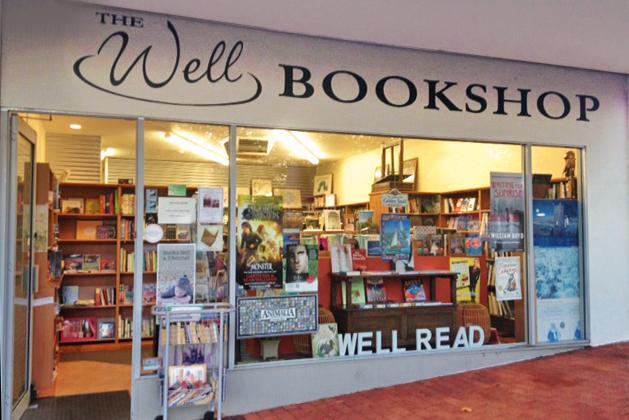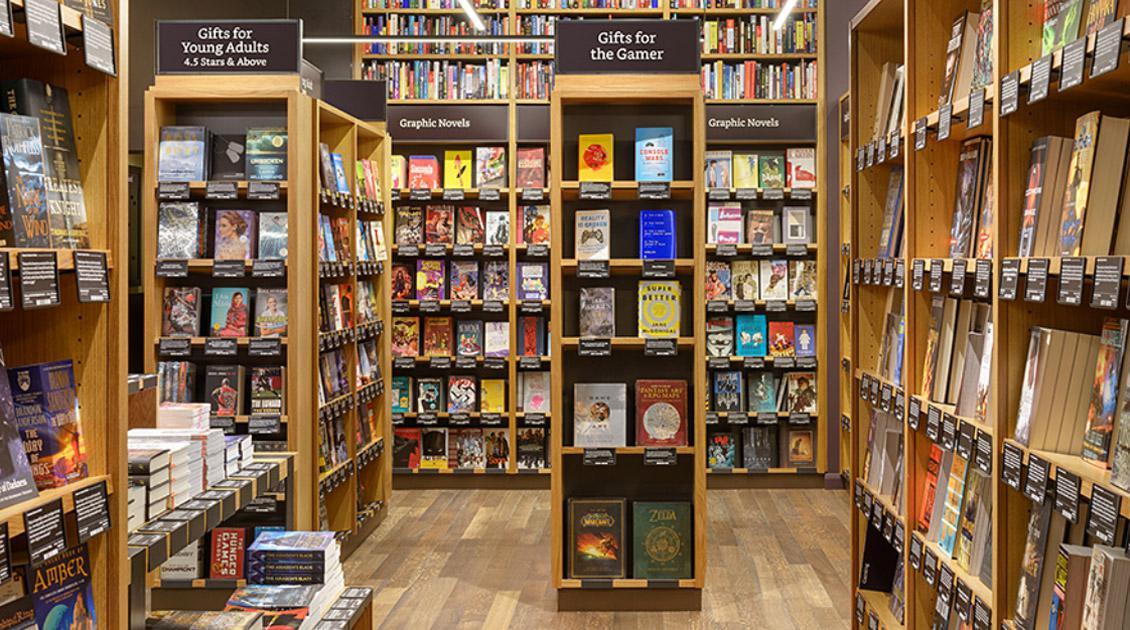The first image is the image on the left, the second image is the image on the right. For the images displayed, is the sentence "One of the images displays an outdoor sign, with vertical letters depicting a book store." factually correct? Answer yes or no. No. 